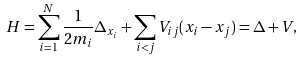Convert formula to latex. <formula><loc_0><loc_0><loc_500><loc_500>H = \sum _ { i = 1 } ^ { N } \frac { 1 } { 2 m _ { i } } \Delta _ { x _ { i } } + \sum _ { i < j } V _ { i j } ( x _ { i } - x _ { j } ) = \Delta + V ,</formula> 